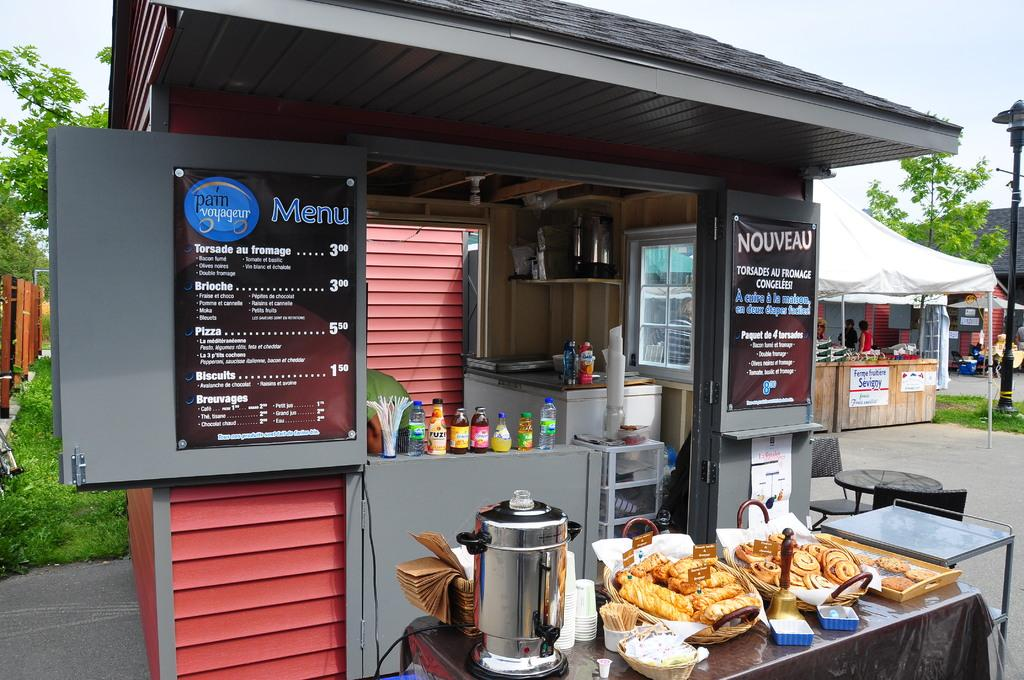<image>
Create a compact narrative representing the image presented. A small food stand has signs reading Menu and Nouveau. 